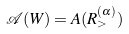Convert formula to latex. <formula><loc_0><loc_0><loc_500><loc_500>\mathcal { A } ( W ) = A ( R _ { > } ^ { ( \alpha ) } )</formula> 